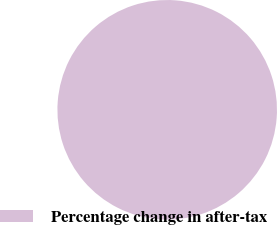<chart> <loc_0><loc_0><loc_500><loc_500><pie_chart><fcel>Percentage change in after-tax<nl><fcel>100.0%<nl></chart> 